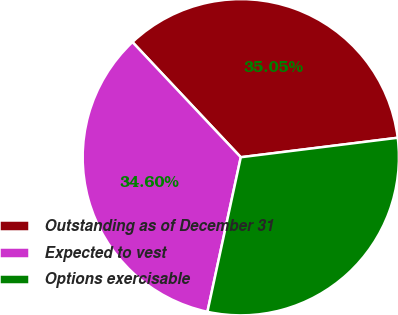<chart> <loc_0><loc_0><loc_500><loc_500><pie_chart><fcel>Outstanding as of December 31<fcel>Expected to vest<fcel>Options exercisable<nl><fcel>35.05%<fcel>34.6%<fcel>30.35%<nl></chart> 